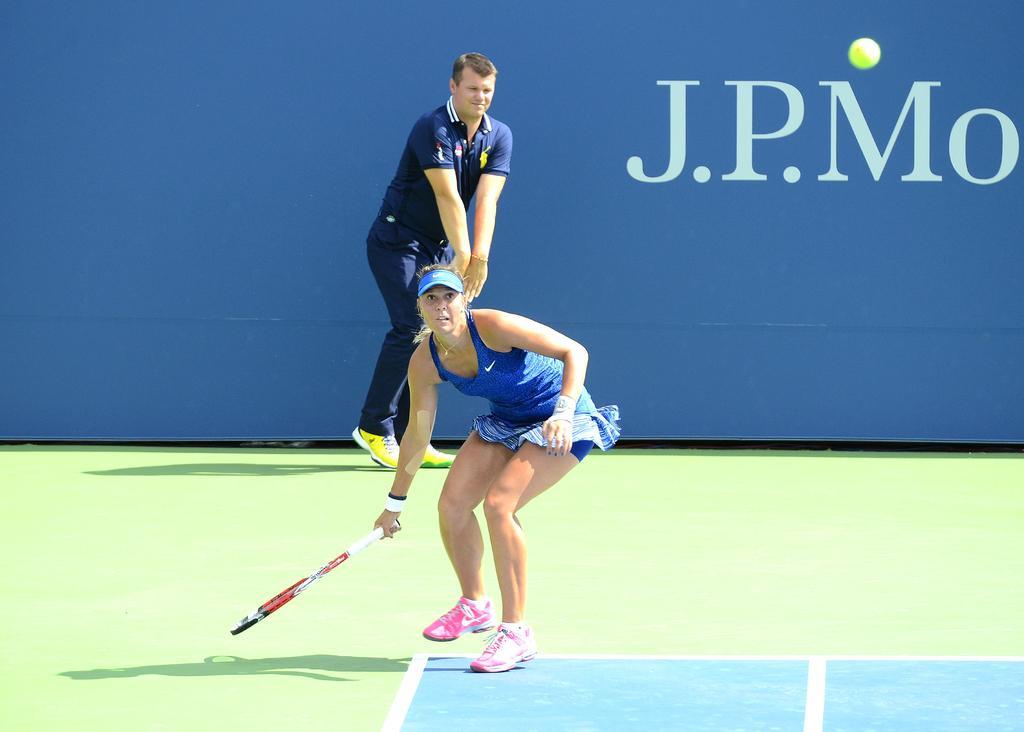In one or two sentences, can you explain what this image depicts? a person is wearing a blue dress and playing tennis, holding a racket in her hand. she is wearing pink shoes. behind her there is another person standing wearing blue dress and yellow shoes. at the back there is a blue background on which j. p. mo is written. the floor is green and blue in color. 